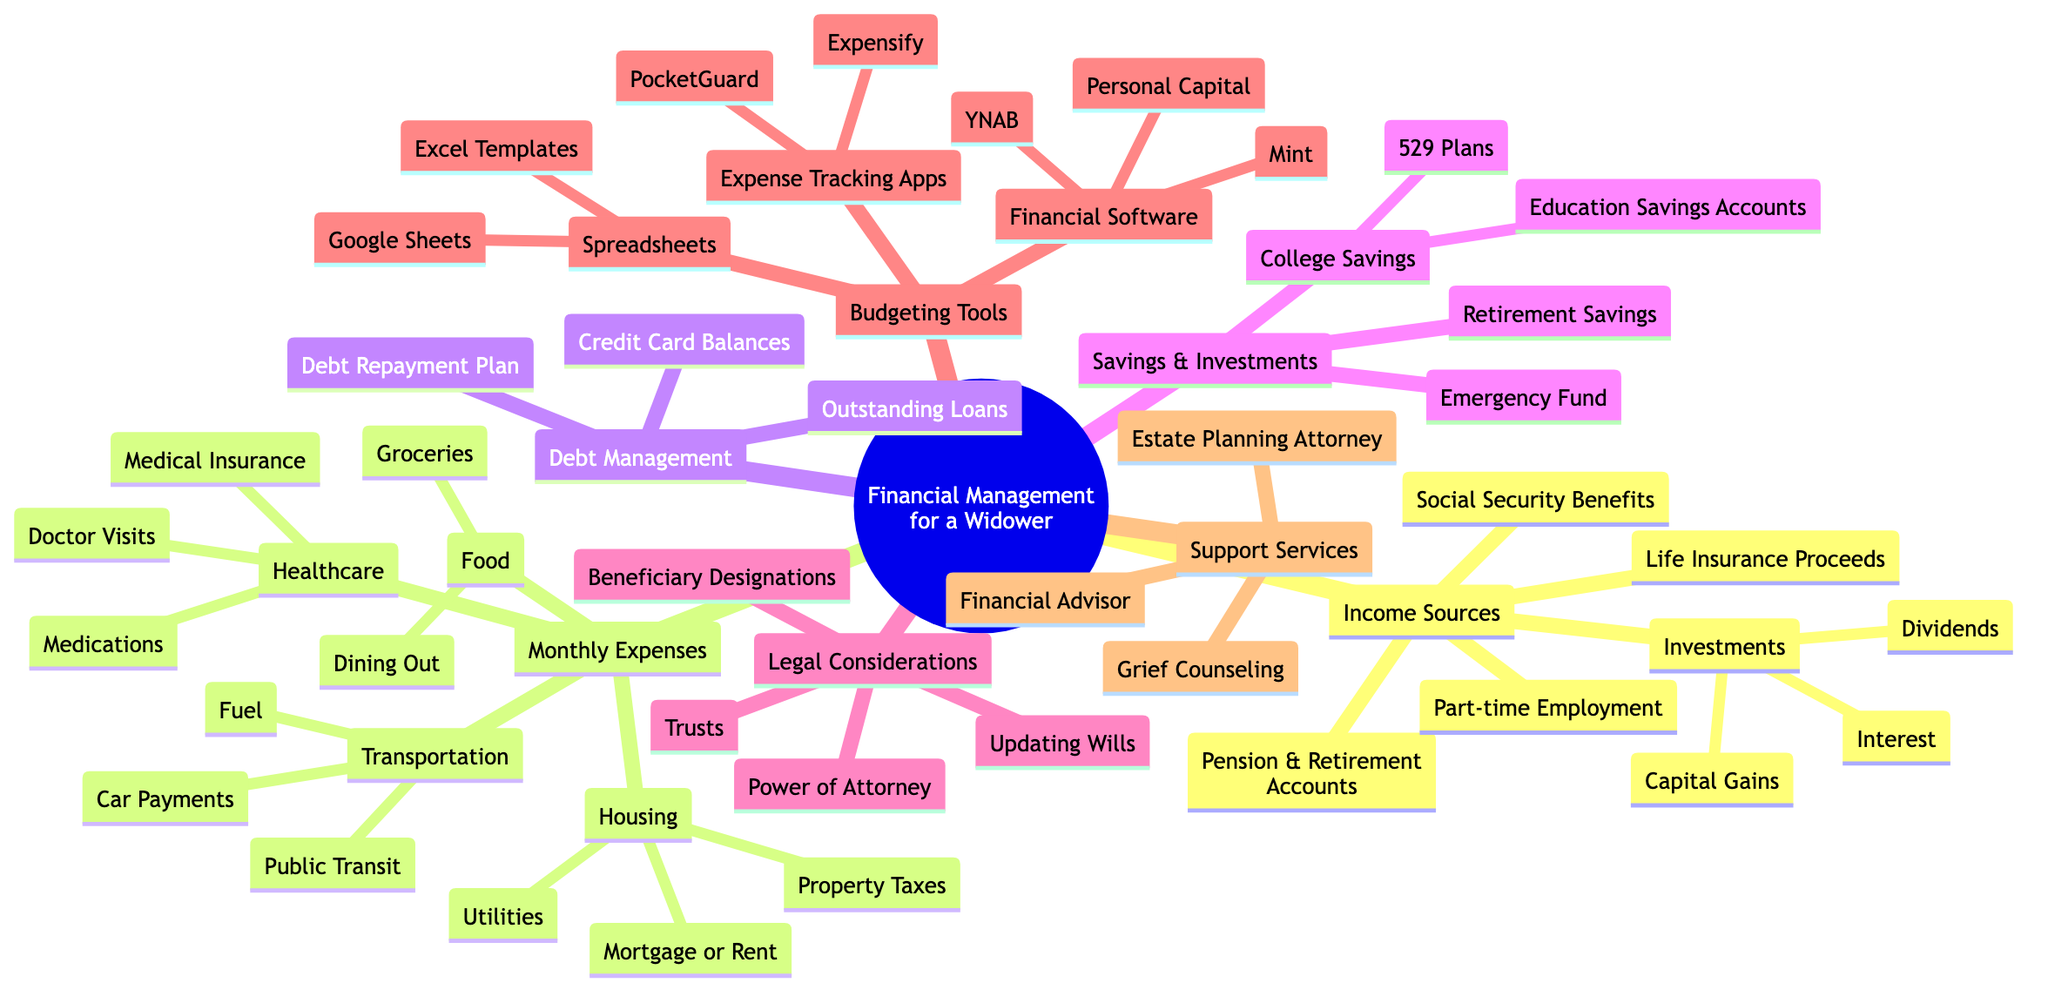what are the main categories in the mind map? The main categories in the mind map include "Income Sources," "Monthly Expenses," "Debt Management," "Savings & Investments," "Legal Considerations," "Budgeting Tools," and "Support Services."
Answer: Income Sources, Monthly Expenses, Debt Management, Savings & Investments, Legal Considerations, Budgeting Tools, Support Services how many income sources are listed? The "Income Sources" category includes five sub-items, which are "Social Security Benefits," "Life Insurance Proceeds," "Pension & Retirement Accounts," "Part-time Employment," and "Investments." Therefore, there are five income sources listed.
Answer: 5 which budgeting tool is mentioned first under Financial Software? The first budgeting tool mentioned under "Financial Software" is "Mint."
Answer: Mint what are the two types of savings mentioned? The two types of savings mentioned are "Emergency Fund" and "Retirement Savings." These are both listed directly under the "Savings & Investments" category.
Answer: Emergency Fund, Retirement Savings what two subcategories fall under monthly expenses relating to food? The two subcategories under "Monthly Expenses" related to food are "Groceries" and "Dining Out." These specify the types of food expenditures.
Answer: Groceries, Dining Out which legal consideration is related to altering future financial arrangements? The legal consideration that is related to altering future financial arrangements is "Updating Wills." That typically involves making changes to how assets will be distributed after passing.
Answer: Updating Wills what is the connection between "Debt Management" and "Monthly Expenses"? The connection is that "Debt Management" relates to "Monthly Expenses" in the sense that managing debt may affect how one allocates funds for monthly expenses. Debt payments can be a significant part of one’s monthly budget.
Answer: affects allocation which support service is related to planning for the distribution of assets? The support service related to planning for the distribution of assets is "Estate Planning Attorney." This professional helps in constructing legal documents to manage the distribution of a person's assets.
Answer: Estate Planning Attorney how many types of college savings accounts are mentioned? There are two types of college savings accounts mentioned, which are "529 Plans" and "Education Savings Accounts," both under the "College Savings" subcategory in "Savings & Investments."
Answer: 2 